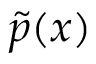Convert formula to latex. <formula><loc_0><loc_0><loc_500><loc_500>\widetilde { p } ( x )</formula> 